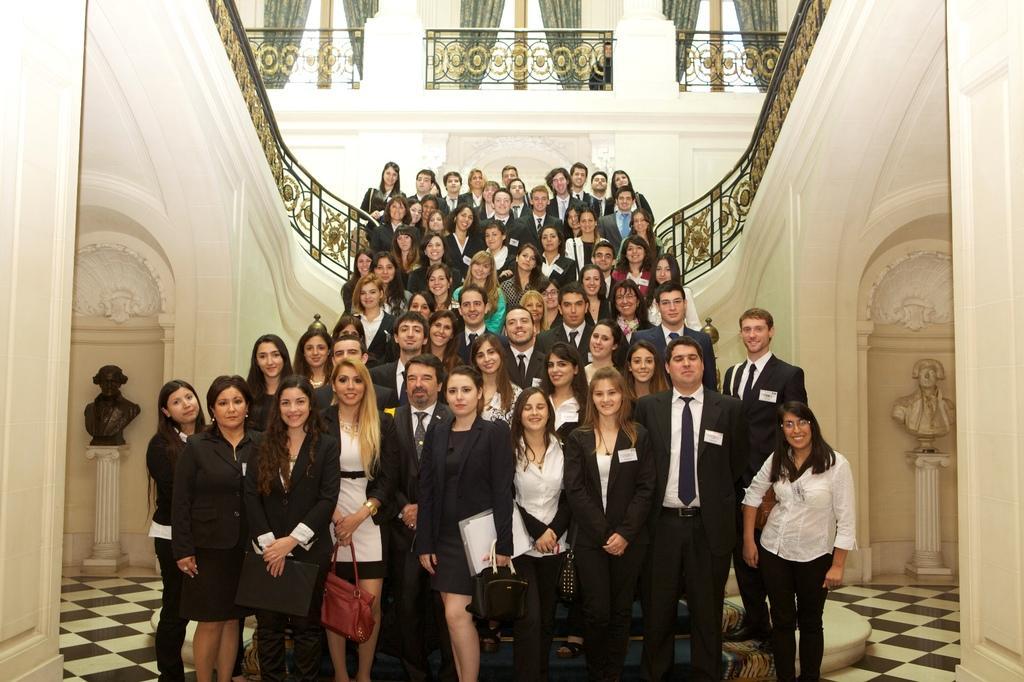Can you describe this image briefly? This image is taken indoors. At the bottom of the image there is a floor. In the background there are a few walls with carvings. On the left and right sides of the image there are two walls, pillars and statues. At the top of the image there are a few railings and windows with curtains. In the middle of the image many people are standing on the stairs and a few are standing on the floor and they are with smiling faces. 